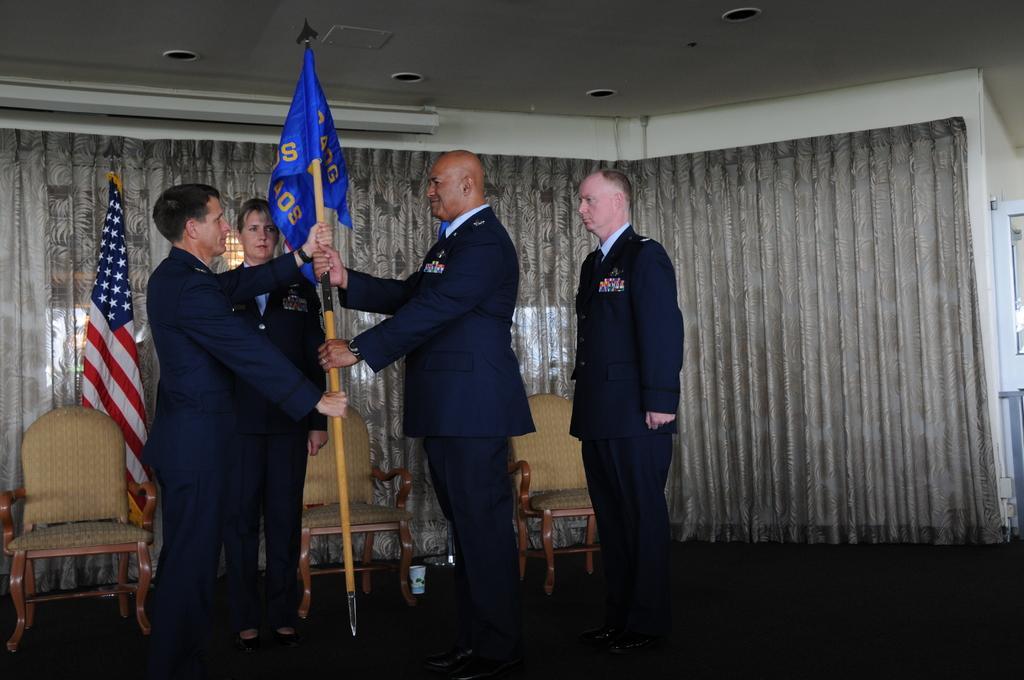Describe this image in one or two sentences. In this picture there are two persons wearing blue suit is standing and holding a stick in their hands which has a blue color attached to it and there is a person standing beside and behind them and there are few chairs,a flag and a curtain in the background. 